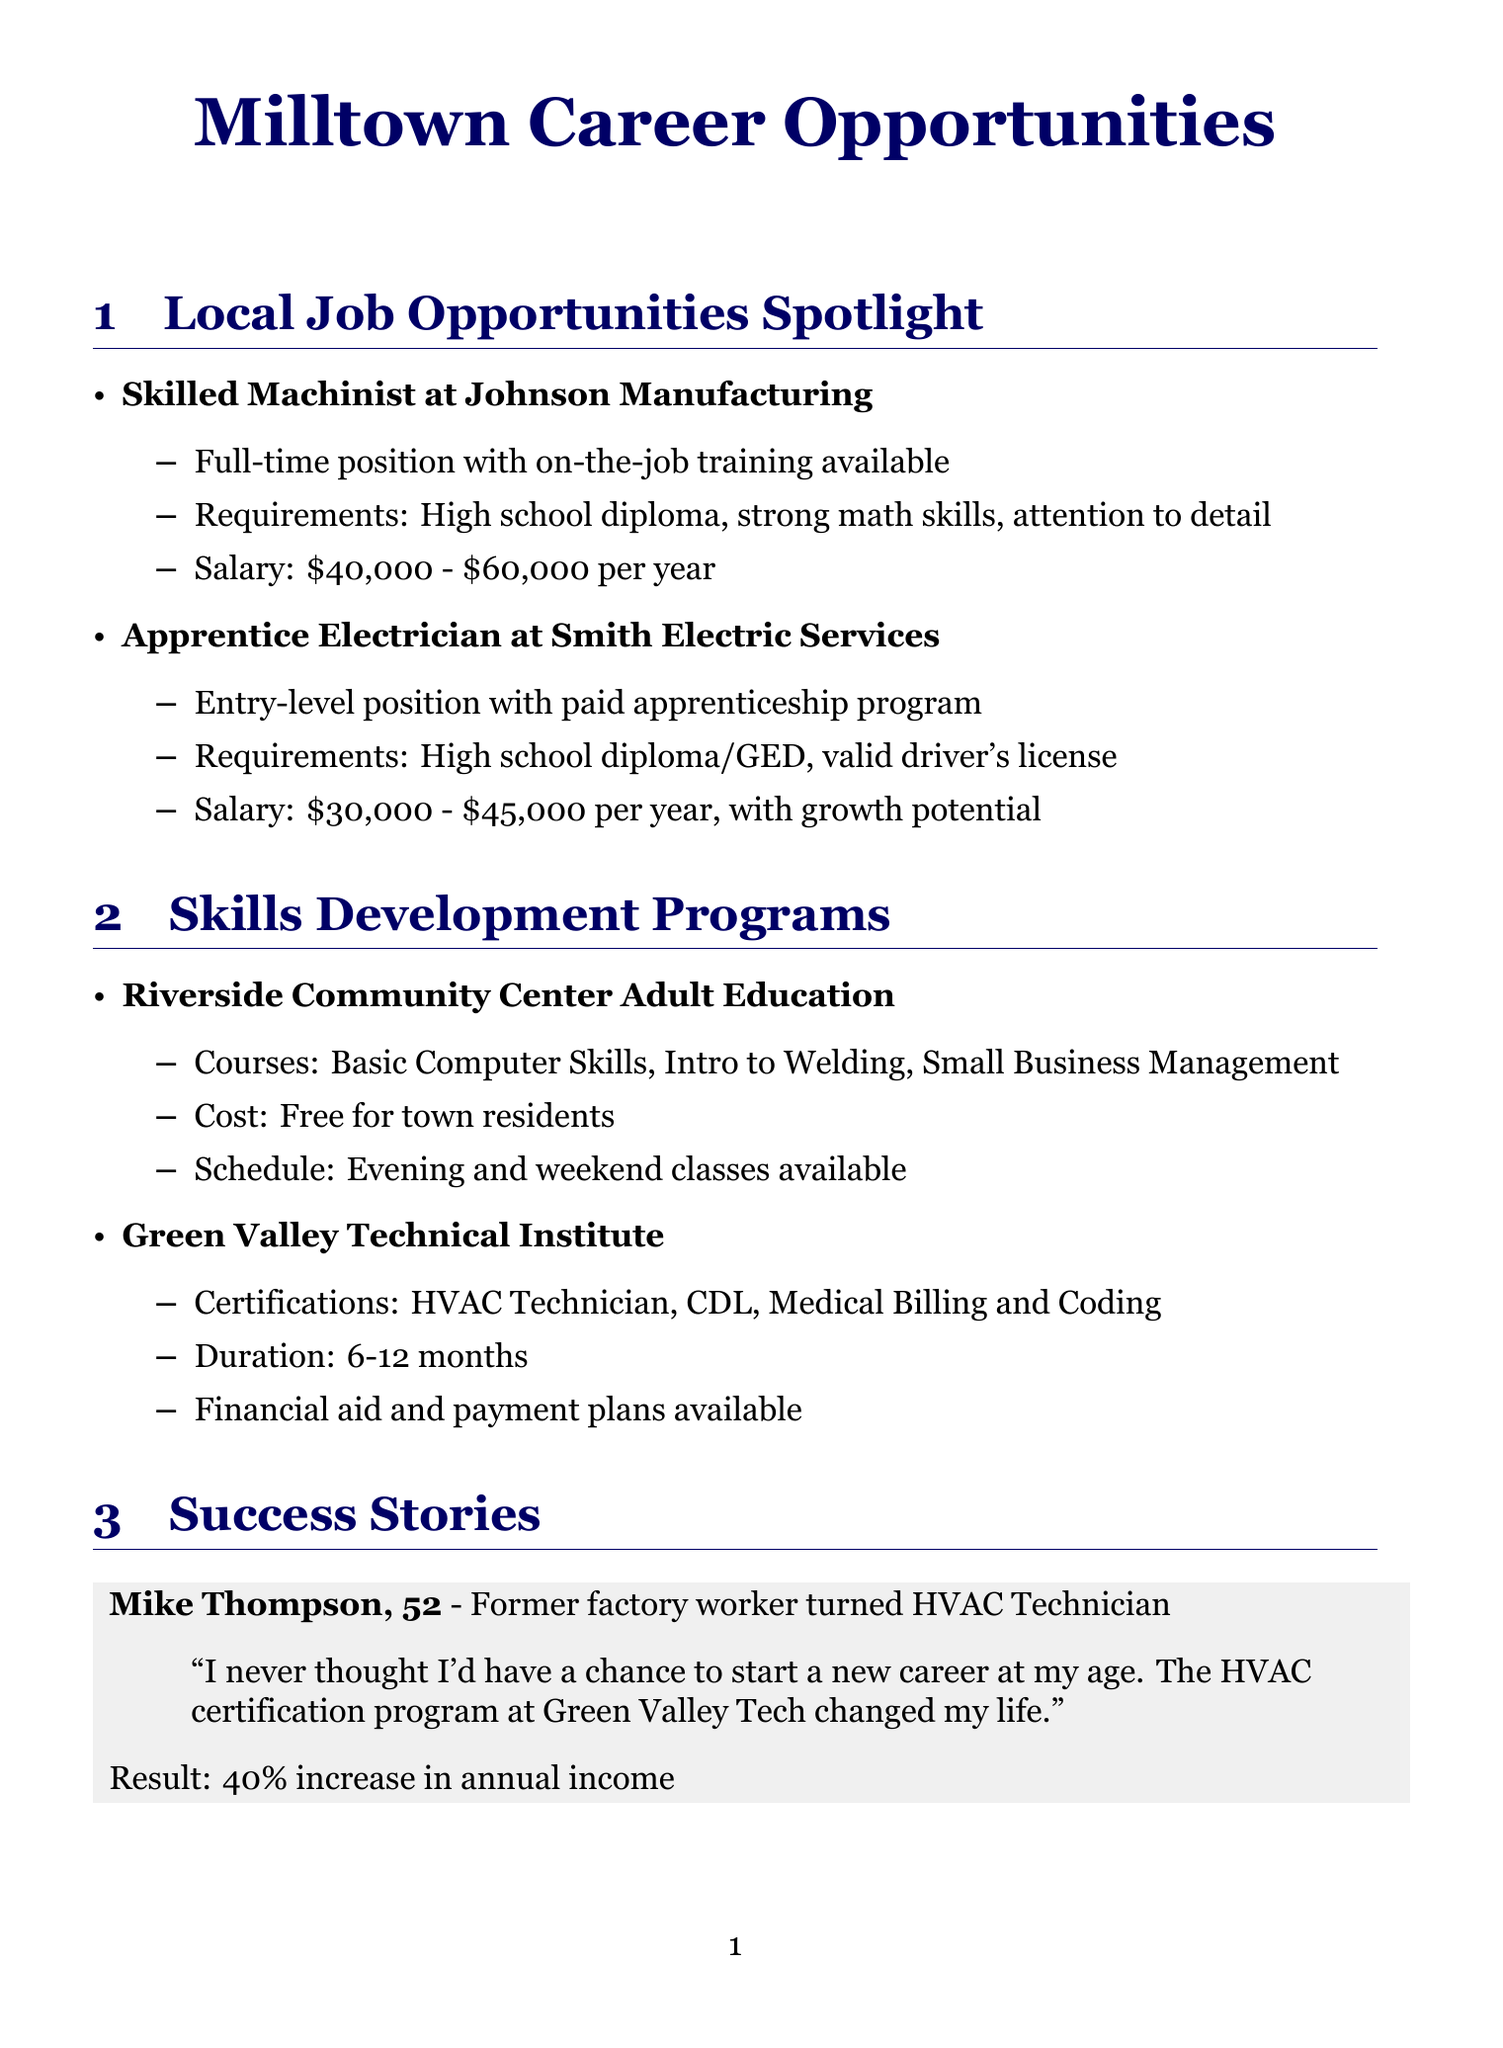What is the job title at Johnson Manufacturing? The job title listed at Johnson Manufacturing is "Skilled Machinist."
Answer: Skilled Machinist What is the salary range for the Apprentice Electrician? The salary range for the Apprentice Electrician at Smith Electric Services is given in the document.
Answer: $30,000 - $45,000 per year, with growth potential Which program offers "Basic Computer Skills"? The program that offers "Basic Computer Skills" is specified in the Skills Development Programs section.
Answer: Riverside Community Center Adult Education Who is Mike Thompson? Mike Thompson is mentioned in the Success Stories section, providing information about his background and new career.
Answer: Former factory worker What percentage increase did Mike Thompson experience in his annual income? The document states the percentage increase in Mike Thompson's annual income after his career change.
Answer: 40% increase What services does the Milltown Public Library provide? The document lists services provided by the Milltown Public Library, including various resources for job seekers.
Answer: Free computer access, resume writing workshops, job search assistance When is the Milltown Job Fair scheduled? The date for the Milltown Job Fair can be found in the Upcoming Events section of the document.
Answer: June 15, 2023 How long do the certifications at Green Valley Technical Institute take to complete? The document specifies the duration of certifications available at Green Valley Technical Institute.
Answer: 6-12 months 